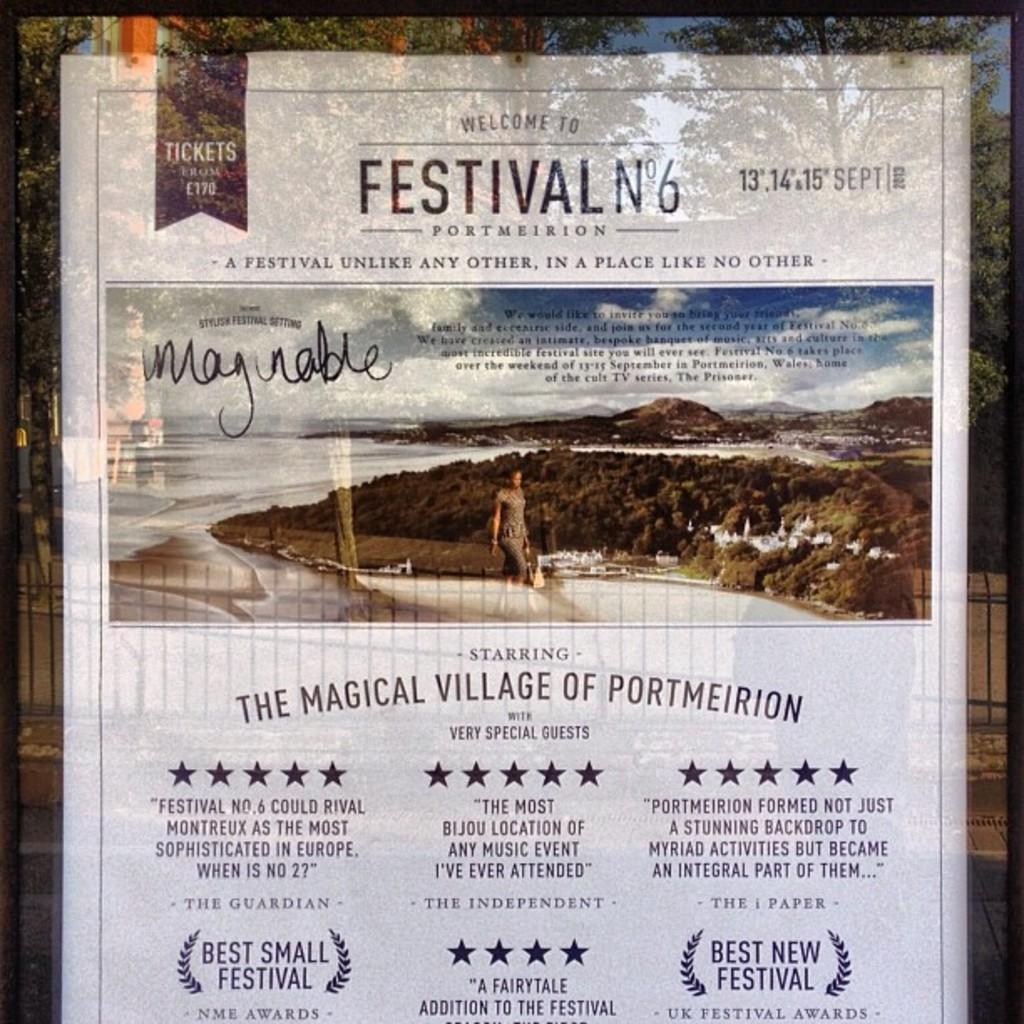<image>
Create a compact narrative representing the image presented. A Welcome to Festival No 6 flyer sits on a table advertising it was the best small festival and best new festival. 